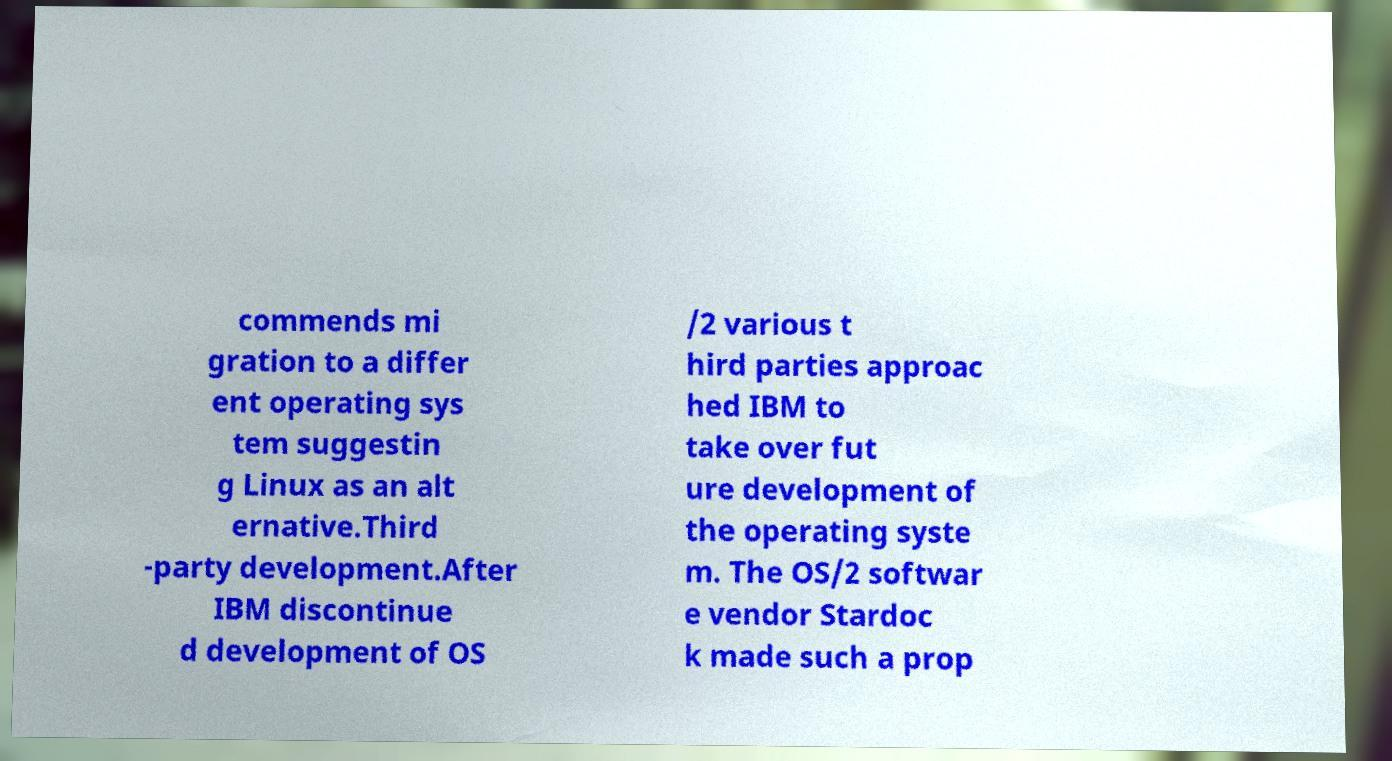Could you extract and type out the text from this image? commends mi gration to a differ ent operating sys tem suggestin g Linux as an alt ernative.Third -party development.After IBM discontinue d development of OS /2 various t hird parties approac hed IBM to take over fut ure development of the operating syste m. The OS/2 softwar e vendor Stardoc k made such a prop 